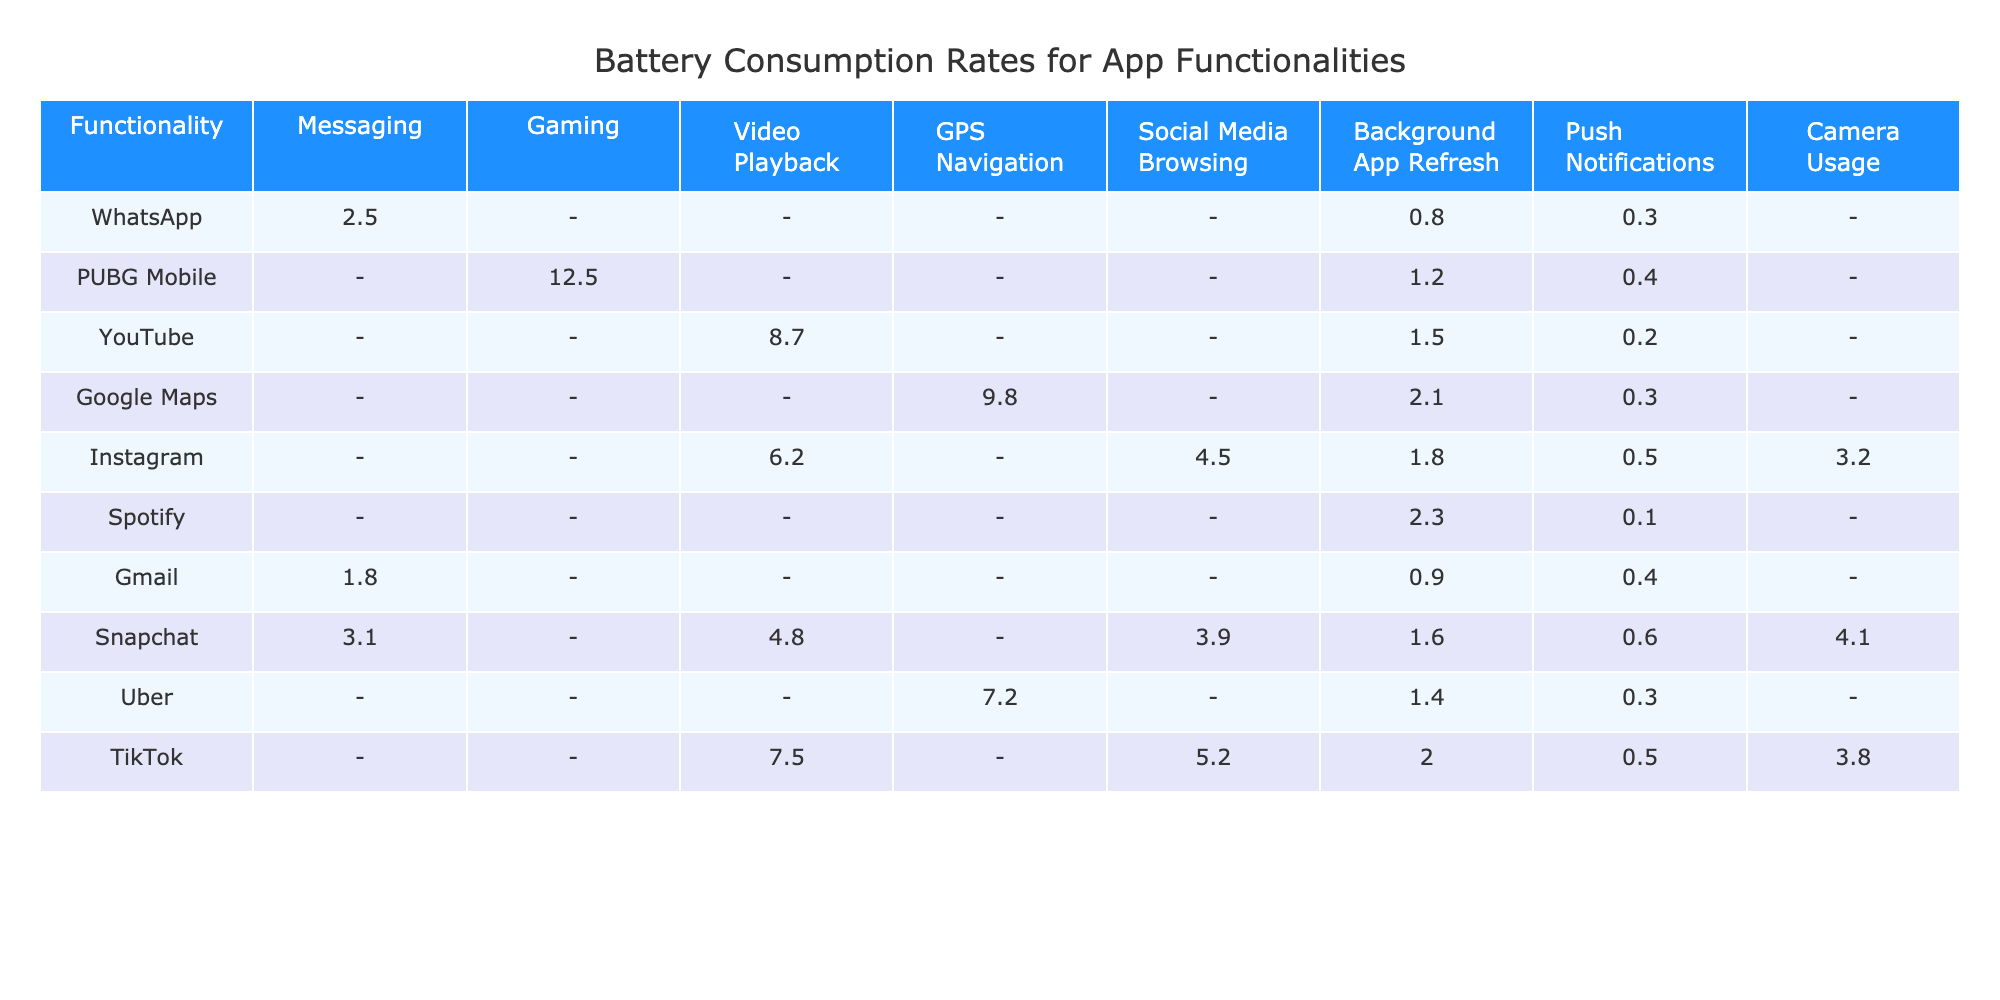What is the battery consumption rate for WhatsApp during Messaging? The table shows that the battery consumption rate for WhatsApp when used in Messaging is 2.5%.
Answer: 2.5% Is there battery consumption data for PUBG Mobile in Messaging? The table indicates that there is no battery consumption data for PUBG Mobile in the Messaging functionality, as it is marked as N/A.
Answer: No Which app consumes the least battery for Push Notifications? By looking at the values for Push Notifications, the lowest value is 0.1, which corresponds to Spotify.
Answer: 0.1 What is the total battery consumption rate for Snapchat when using Camera Usage and Background App Refresh? The battery consumption for Camera Usage is 4.1 and for Background App Refresh is 1.6. Adding these gives 4.1 + 1.6 = 5.7.
Answer: 5.7 Does Instagram consume more battery for Video Playback or Social Media Browsing? Instagram consumes 6.2 for Social Media Browsing and has no data for Video Playback (N/A). Thus, it consumes more battery for Social Media Browsing.
Answer: Yes, more for Social Media Browsing Which app has the highest battery consumption for GPS Navigation? Looking at the table, Google Maps has the highest consumption at 9.8 for GPS Navigation.
Answer: Google Maps What is the average battery consumption rate for the functionalities across the apps listed? To find this, I sum all the known values: (2.5 + 1.8 + 3.1 + 12.5 + 8.7 + 9.8 + 4.5 + 6.2 + 5.2 + 7.5 + 1.2 + 2.1 + 1.5 + 2.3 + 0.9 + 1.4 + 0.6 + 0.3 + 0.5 + 0.2 + 0.1 + 0.3 + 0.4 + 0.5 + 3.2 + 4.1)/20 (adjusting for N/A) = 4.14 (approx)
Answer: 4.14 Is it true that every app has data listed for Background App Refresh? The table shows that not every app has data listed for Background App Refresh, indicating some are N/A.
Answer: No Which two functionalities have the highest recorded battery consumption from any app? The highest recorded consumption rates are 12.5 for PUBG Mobile (Gaming) and 9.8 for Google Maps (GPS Navigation).
Answer: 12.5 and 9.8 What is the total battery consumption for TikTok's functionalities listed? For TikTok, the listed functionalities are Video Playback (7.5), Social Media Browsing (5.2), Background App Refresh (2.0), and Push Notifications (0.5). Summing these gives 7.5 + 5.2 + 2.0 + 0.5 = 15.2.
Answer: 15.2 